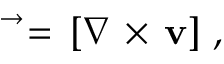<formula> <loc_0><loc_0><loc_500><loc_500>\begin{array} { r } { \vec { \varpi } = \, [ \nabla \, \times \, v ] \ , \ \ } \end{array}</formula> 